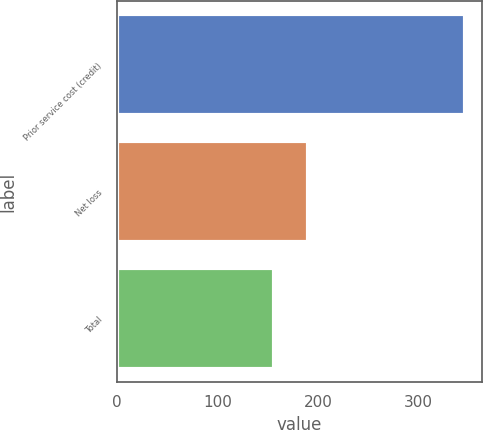<chart> <loc_0><loc_0><loc_500><loc_500><bar_chart><fcel>Prior service cost (credit)<fcel>Net loss<fcel>Total<nl><fcel>346<fcel>190<fcel>156<nl></chart> 